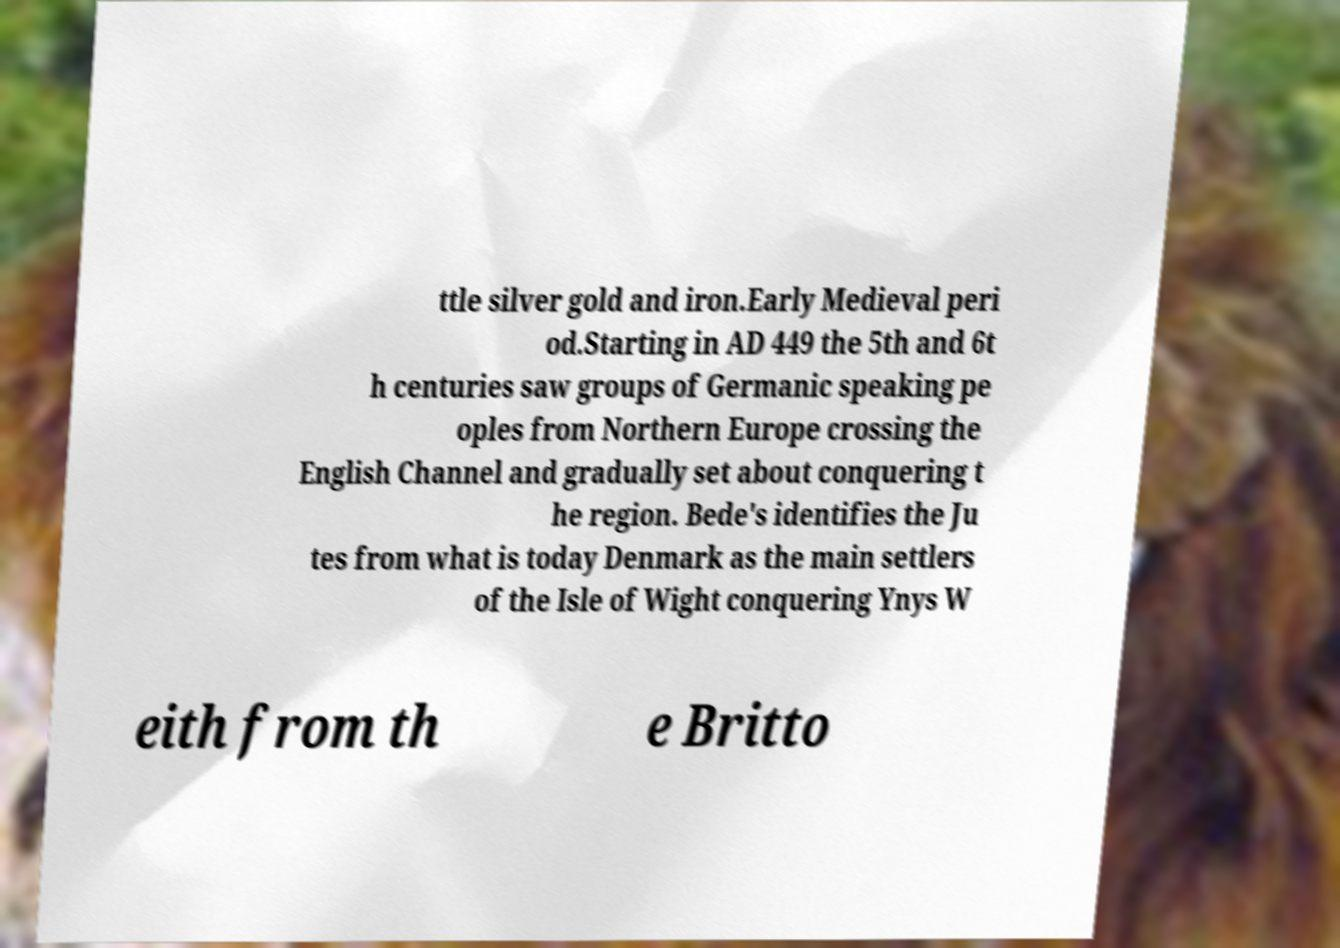For documentation purposes, I need the text within this image transcribed. Could you provide that? ttle silver gold and iron.Early Medieval peri od.Starting in AD 449 the 5th and 6t h centuries saw groups of Germanic speaking pe oples from Northern Europe crossing the English Channel and gradually set about conquering t he region. Bede's identifies the Ju tes from what is today Denmark as the main settlers of the Isle of Wight conquering Ynys W eith from th e Britto 